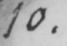What is written in this line of handwriting? 10 . 